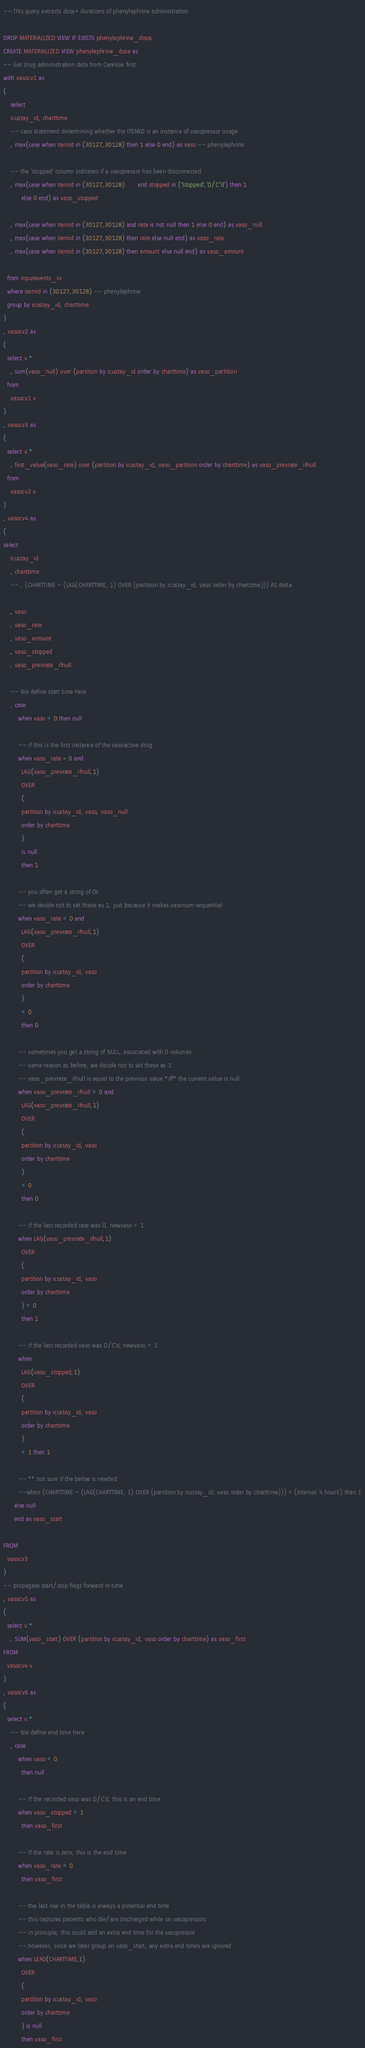Convert code to text. <code><loc_0><loc_0><loc_500><loc_500><_SQL_>-- This query extracts dose+durations of phenylephrine administration

DROP MATERIALIZED VIEW IF EXISTS phenylephrine_dose;
CREATE MATERIALIZED VIEW phenylephrine_dose as
-- Get drug administration data from CareVue first
with vasocv1 as
(
    select
    icustay_id, charttime
    -- case statement determining whether the ITEMID is an instance of vasopressor usage
    , max(case when itemid in (30127,30128) then 1 else 0 end) as vaso -- phenylephrine

    -- the 'stopped' column indicates if a vasopressor has been disconnected
    , max(case when itemid in (30127,30128)       and stopped in ('Stopped','D/C''d') then 1
          else 0 end) as vaso_stopped

    , max(case when itemid in (30127,30128) and rate is not null then 1 else 0 end) as vaso_null
    , max(case when itemid in (30127,30128) then rate else null end) as vaso_rate
    , max(case when itemid in (30127,30128) then amount else null end) as vaso_amount

  from inputevents_cv
  where itemid in (30127,30128) -- phenylephrine
  group by icustay_id, charttime
)
, vasocv2 as
(
  select v.*
    , sum(vaso_null) over (partition by icustay_id order by charttime) as vaso_partition
  from
    vasocv1 v
)
, vasocv3 as
(
  select v.*
    , first_value(vaso_rate) over (partition by icustay_id, vaso_partition order by charttime) as vaso_prevrate_ifnull
  from
    vasocv2 v
)
, vasocv4 as
(
select
    icustay_id
    , charttime
    -- , (CHARTTIME - (LAG(CHARTTIME, 1) OVER (partition by icustay_id, vaso order by charttime))) AS delta

    , vaso
    , vaso_rate
    , vaso_amount
    , vaso_stopped
    , vaso_prevrate_ifnull

    -- We define start time here
    , case
        when vaso = 0 then null

        -- if this is the first instance of the vasoactive drug
        when vaso_rate > 0 and
          LAG(vaso_prevrate_ifnull,1)
          OVER
          (
          partition by icustay_id, vaso, vaso_null
          order by charttime
          )
          is null
          then 1

        -- you often get a string of 0s
        -- we decide not to set these as 1, just because it makes vasonum sequential
        when vaso_rate = 0 and
          LAG(vaso_prevrate_ifnull,1)
          OVER
          (
          partition by icustay_id, vaso
          order by charttime
          )
          = 0
          then 0

        -- sometimes you get a string of NULL, associated with 0 volumes
        -- same reason as before, we decide not to set these as 1
        -- vaso_prevrate_ifnull is equal to the previous value *iff* the current value is null
        when vaso_prevrate_ifnull = 0 and
          LAG(vaso_prevrate_ifnull,1)
          OVER
          (
          partition by icustay_id, vaso
          order by charttime
          )
          = 0
          then 0

        -- If the last recorded rate was 0, newvaso = 1
        when LAG(vaso_prevrate_ifnull,1)
          OVER
          (
          partition by icustay_id, vaso
          order by charttime
          ) = 0
          then 1

        -- If the last recorded vaso was D/C'd, newvaso = 1
        when
          LAG(vaso_stopped,1)
          OVER
          (
          partition by icustay_id, vaso
          order by charttime
          )
          = 1 then 1

        -- ** not sure if the below is needed
        --when (CHARTTIME - (LAG(CHARTTIME, 1) OVER (partition by icustay_id, vaso order by charttime))) > (interval '4 hours') then 1
      else null
      end as vaso_start

FROM
  vasocv3
)
-- propagate start/stop flags forward in time
, vasocv5 as
(
  select v.*
    , SUM(vaso_start) OVER (partition by icustay_id, vaso order by charttime) as vaso_first
FROM
  vasocv4 v
)
, vasocv6 as
(
  select v.*
    -- We define end time here
    , case
        when vaso = 0
          then null

        -- If the recorded vaso was D/C'd, this is an end time
        when vaso_stopped = 1
          then vaso_first

        -- If the rate is zero, this is the end time
        when vaso_rate = 0
          then vaso_first

        -- the last row in the table is always a potential end time
        -- this captures patients who die/are discharged while on vasopressors
        -- in principle, this could add an extra end time for the vasopressor
        -- however, since we later group on vaso_start, any extra end times are ignored
        when LEAD(CHARTTIME,1)
          OVER
          (
          partition by icustay_id, vaso
          order by charttime
          ) is null
          then vaso_first
</code> 